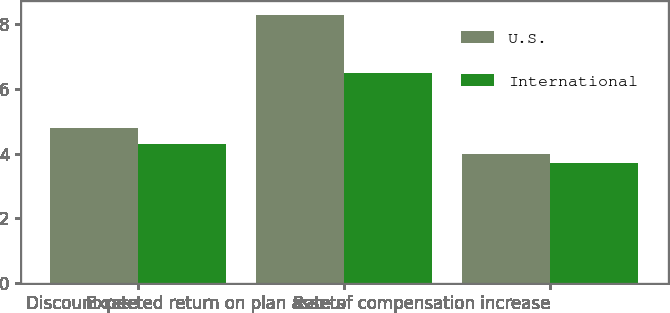Convert chart to OTSL. <chart><loc_0><loc_0><loc_500><loc_500><stacked_bar_chart><ecel><fcel>Discount rate<fcel>Expected return on plan assets<fcel>Rate of compensation increase<nl><fcel>U.S.<fcel>4.8<fcel>8.3<fcel>4<nl><fcel>International<fcel>4.3<fcel>6.5<fcel>3.7<nl></chart> 